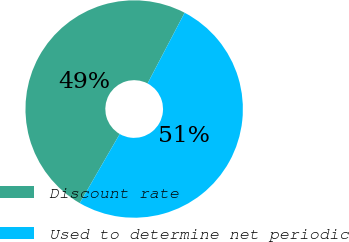Convert chart. <chart><loc_0><loc_0><loc_500><loc_500><pie_chart><fcel>Discount rate<fcel>Used to determine net periodic<nl><fcel>49.34%<fcel>50.66%<nl></chart> 